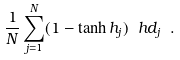Convert formula to latex. <formula><loc_0><loc_0><loc_500><loc_500>\frac { 1 } { N } \sum _ { j = 1 } ^ { N } ( 1 - \tanh h _ { j } ) \ h d _ { j } \ .</formula> 